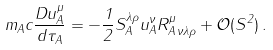<formula> <loc_0><loc_0><loc_500><loc_500>m _ { A } c \frac { D u _ { A } ^ { \mu } } { d \tau _ { A } } = - \frac { 1 } { 2 } S _ { A } ^ { \lambda \rho } u _ { A } ^ { \nu } R ^ { \mu } _ { A \, \nu \lambda \rho } + \mathcal { O } ( S ^ { 2 } ) \, .</formula> 